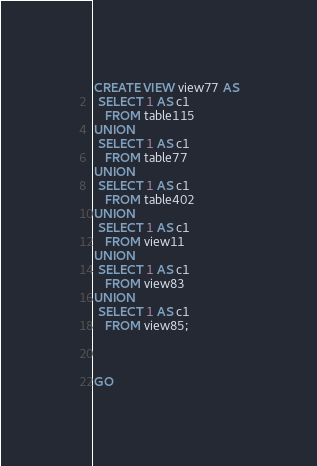Convert code to text. <code><loc_0><loc_0><loc_500><loc_500><_SQL_>CREATE VIEW view77 AS
 SELECT 1 AS c1
   FROM table115
UNION
 SELECT 1 AS c1
   FROM table77
UNION
 SELECT 1 AS c1
   FROM table402
UNION
 SELECT 1 AS c1
   FROM view11
UNION
 SELECT 1 AS c1
   FROM view83
UNION
 SELECT 1 AS c1
   FROM view85;



GO</code> 